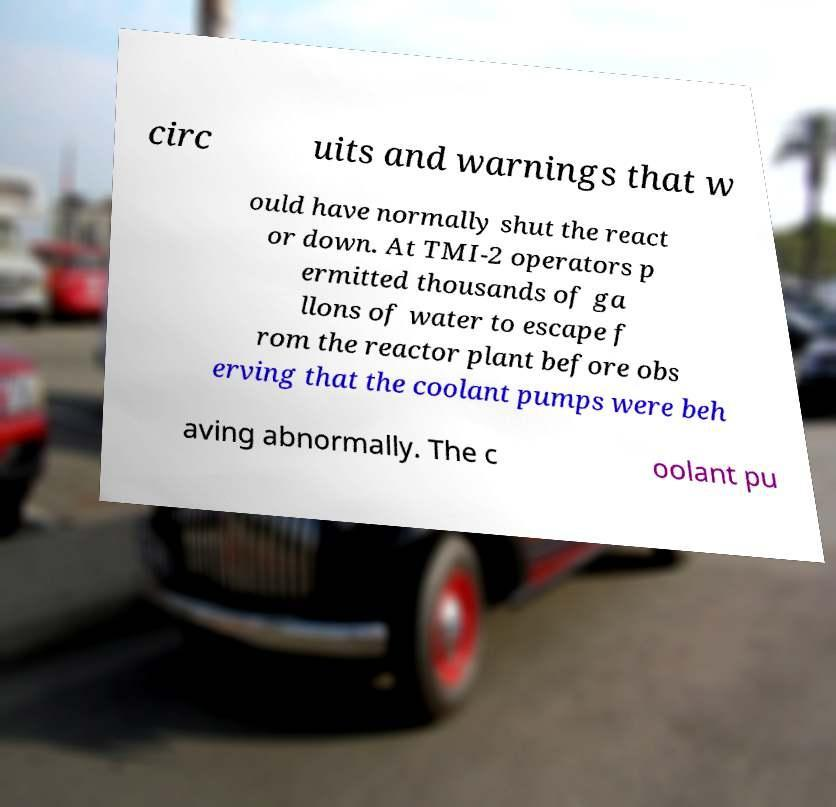Please identify and transcribe the text found in this image. circ uits and warnings that w ould have normally shut the react or down. At TMI-2 operators p ermitted thousands of ga llons of water to escape f rom the reactor plant before obs erving that the coolant pumps were beh aving abnormally. The c oolant pu 